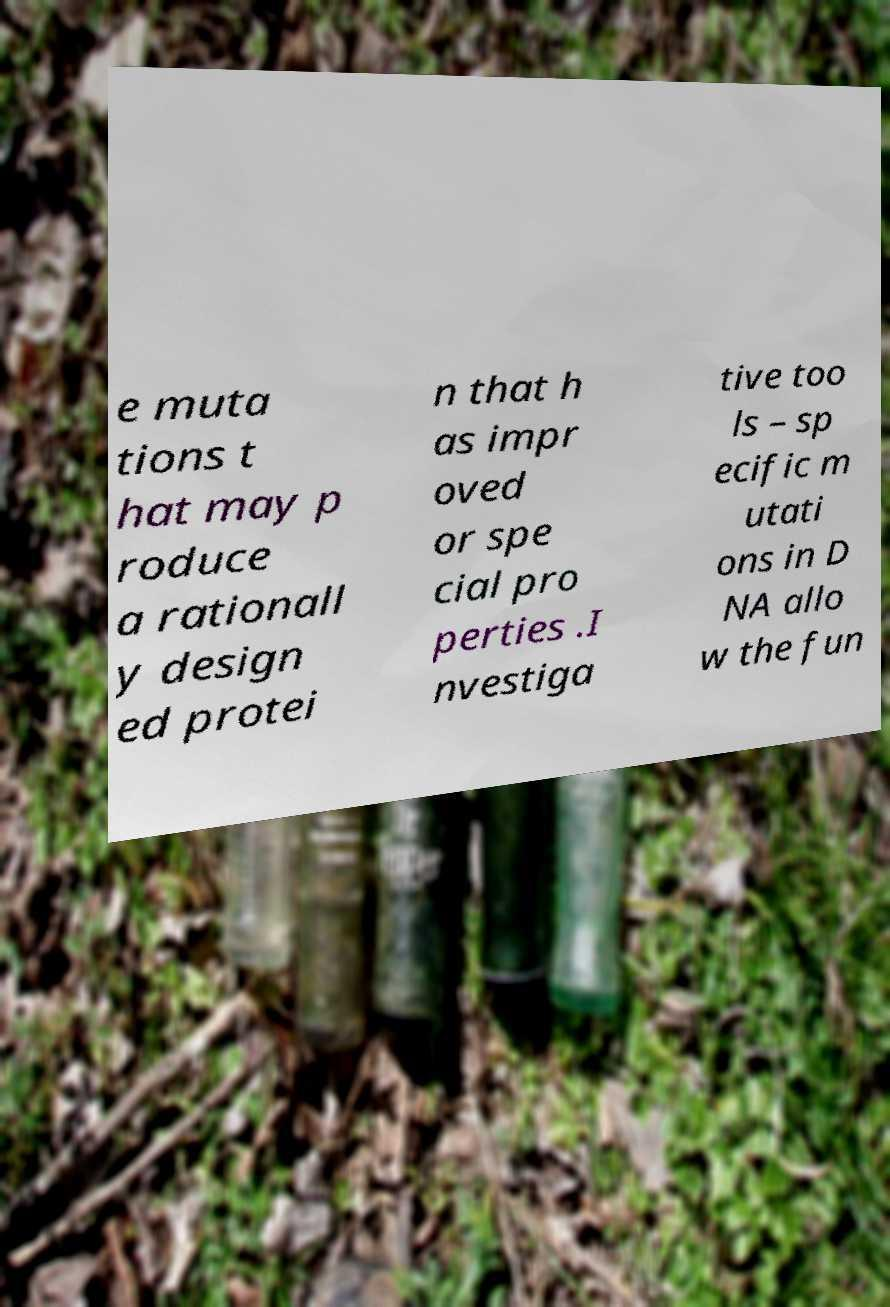Please identify and transcribe the text found in this image. e muta tions t hat may p roduce a rationall y design ed protei n that h as impr oved or spe cial pro perties .I nvestiga tive too ls – sp ecific m utati ons in D NA allo w the fun 